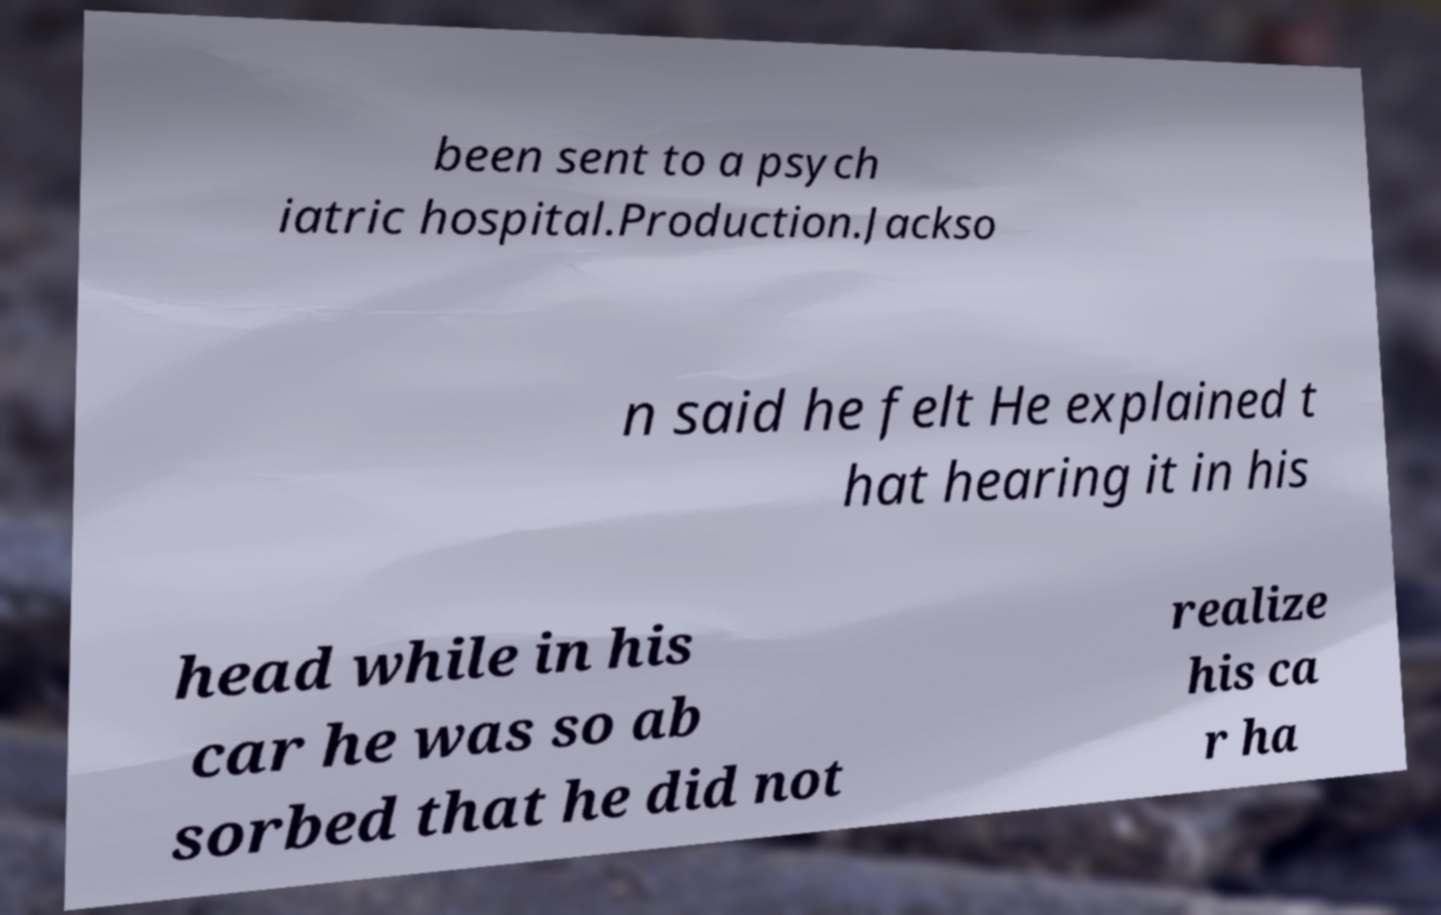Can you read and provide the text displayed in the image?This photo seems to have some interesting text. Can you extract and type it out for me? been sent to a psych iatric hospital.Production.Jackso n said he felt He explained t hat hearing it in his head while in his car he was so ab sorbed that he did not realize his ca r ha 